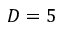Convert formula to latex. <formula><loc_0><loc_0><loc_500><loc_500>D = 5</formula> 